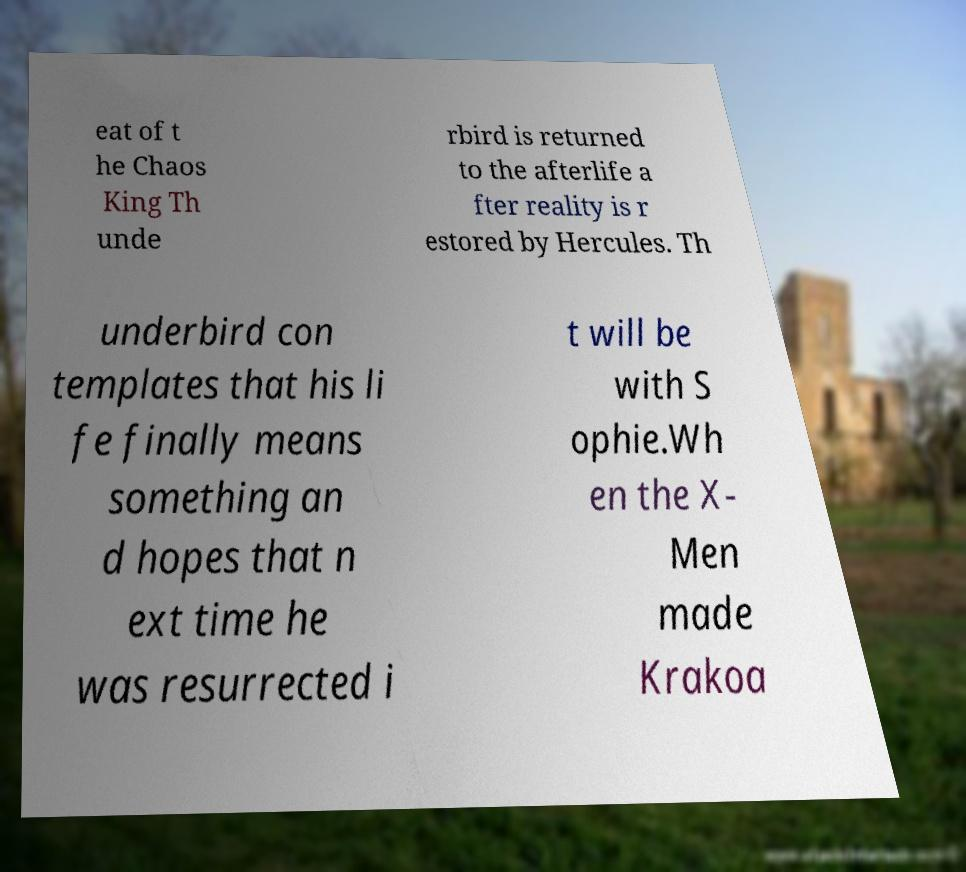Please read and relay the text visible in this image. What does it say? eat of t he Chaos King Th unde rbird is returned to the afterlife a fter reality is r estored by Hercules. Th underbird con templates that his li fe finally means something an d hopes that n ext time he was resurrected i t will be with S ophie.Wh en the X- Men made Krakoa 